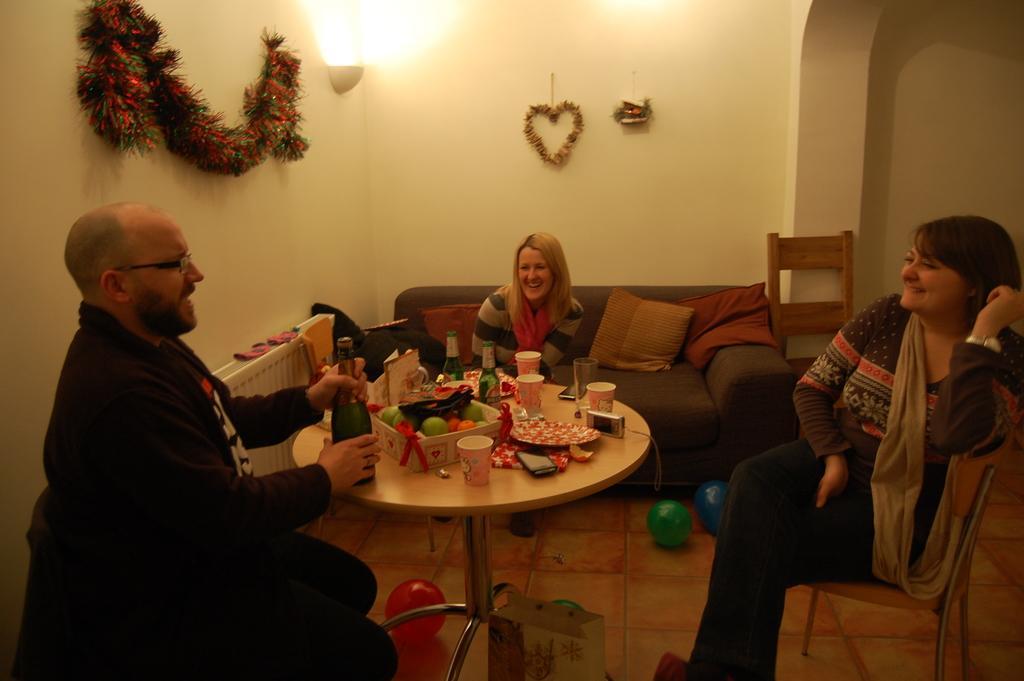Could you give a brief overview of what you see in this image? This picture shows two women and a man sitting in the room. A man is sitting in front of a table on which some food items and a bottle is placed. He is wearing spectacles. Women are sitting in a chair and sofa. In the background there is a light, garland and a wall here. 